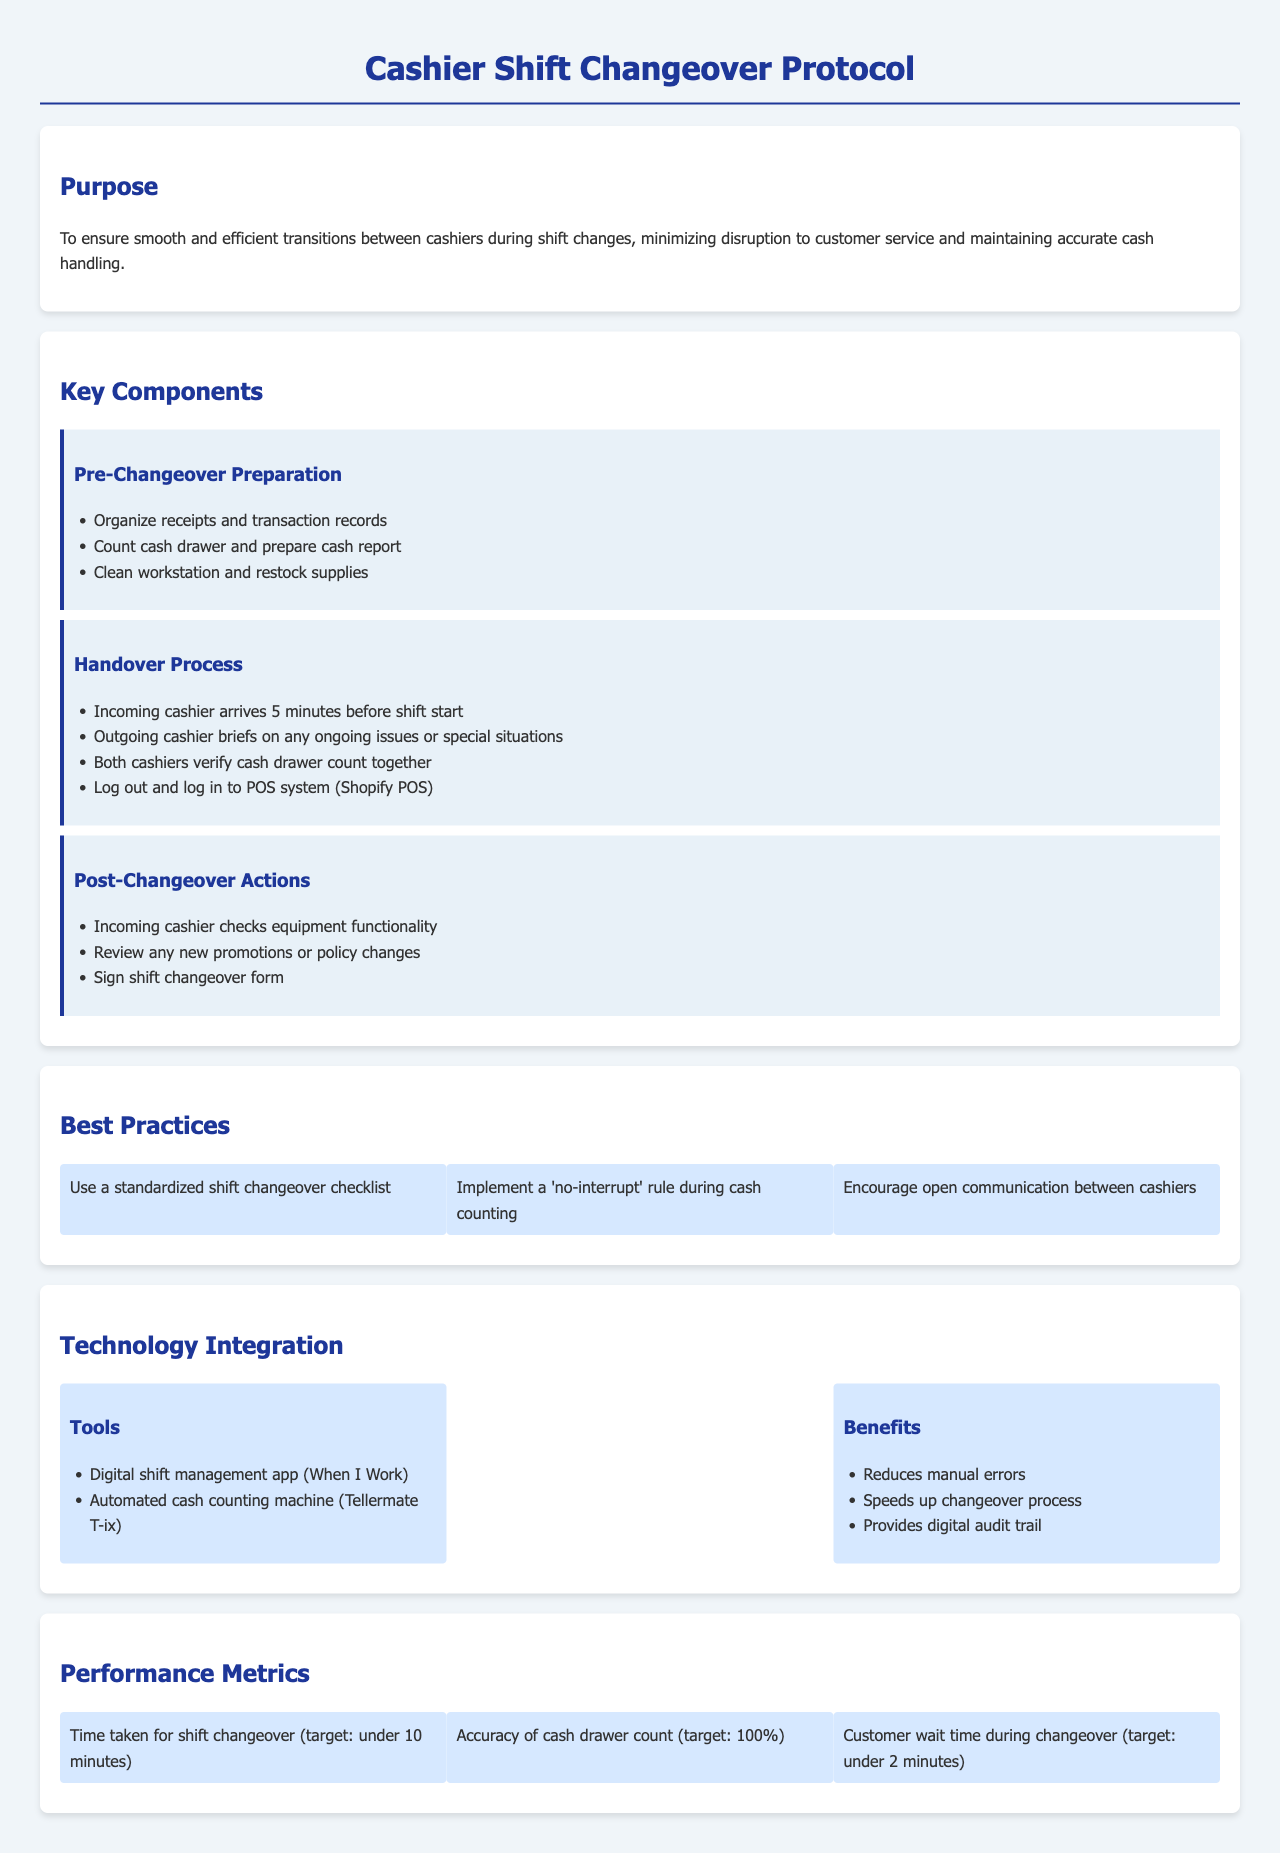What is the purpose of the protocol? The purpose is to ensure smooth and efficient transitions between cashiers during shift changes, minimizing disruption to customer service and maintaining accurate cash handling.
Answer: To ensure smooth and efficient transitions What should be organized during pre-changeover preparation? Receipts and transaction records should be organized as part of the pre-changeover preparation.
Answer: Receipts and transaction records Who arrives five minutes before the shift start? The incoming cashier is the one who arrives five minutes before the shift start.
Answer: Incoming cashier What is the target time for shift changeover? The target time for shift changeover is specified to be under 10 minutes.
Answer: Under 10 minutes Which digital tool is mentioned for shift management? The digital shift management app mentioned is "When I Work."
Answer: When I Work What should both cashiers do during the handover process? During the handover process, both cashiers should verify the cash drawer count together.
Answer: Verify cash drawer count What are the targets for customer wait time during changeovers? The target for customer wait time during changeovers is under 2 minutes.
Answer: Under 2 minutes What is a best practice to follow during cash counting? A best practice is to implement a 'no-interrupt' rule during cash counting.
Answer: No-interrupt rule What should the incoming cashier check after the changeover? The incoming cashier should check equipment functionality after the changeover.
Answer: Equipment functionality 